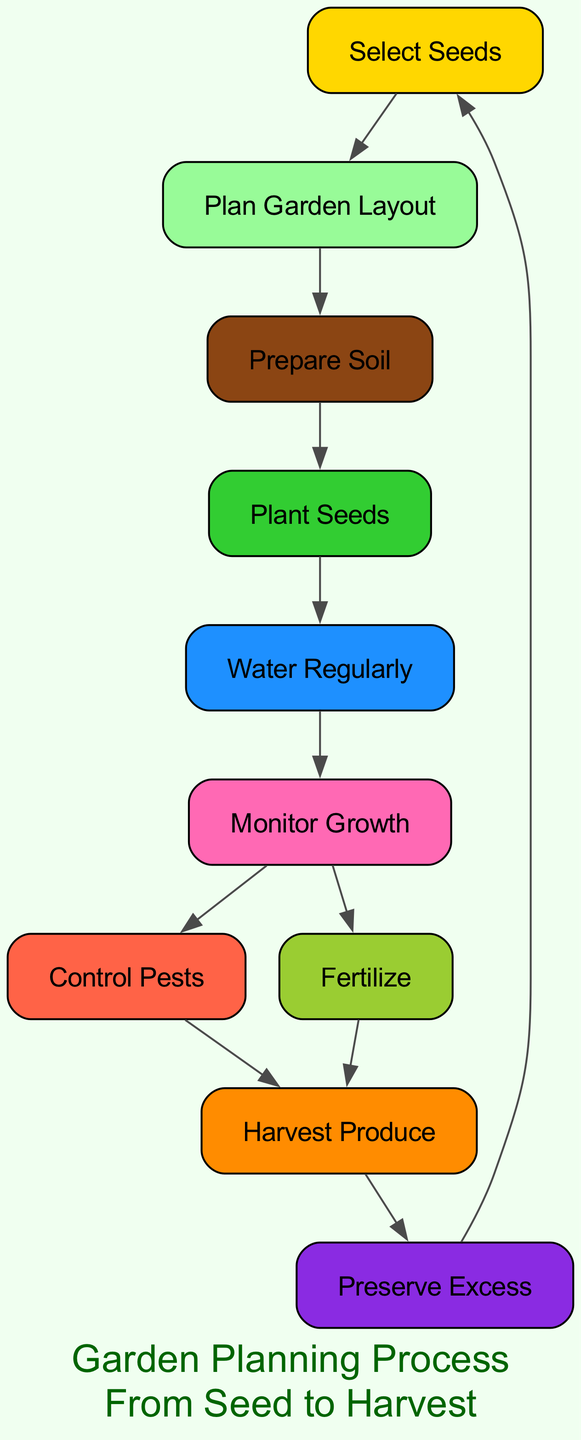What is the first step in the garden planning process? The first node in the diagram is "Select Seeds", which indicates that this is the starting point of the garden planning process.
Answer: Select Seeds How many nodes are present in the diagram? The diagram lists 10 different nodes related to the garden planning process. By counting each unique node, we confirm the total.
Answer: 10 What is the relationship between "Plant Seeds" and "Water Regularly"? The diagram shows a directed edge from "Plant Seeds" to "Water Regularly", indicating that watering occurs after planting seeds.
Answer: "Plant Seeds" to "Water Regularly" Which step comes after "Monitor Growth"? From the diagram, "Control Pests" and "Fertilize" both follow "Monitor Growth" as indicated by the directed edges leading from "Monitor Growth".
Answer: Control Pests, Fertilize What node immediately precedes "Harvest Produce"? The diagram indicates two nodes lead directly to "Harvest Produce", which are "Control Pests" and "Fertilize", making either the immediate predecessor.
Answer: Control Pests, Fertilize What color represents the "Prepare Soil" stage? The diagram uses a specific color for the "Prepare Soil" node, which is saddle brown, as indicated in the predefined colors for stages in the diagram.
Answer: Saddle brown How many edges are there in the diagram? By counting the relationships between the nodes, there are 10 directed edges connecting them in the garden planning process.
Answer: 10 What is the last step in the garden planning process? According to the final node in the directed graph, "Preserve Excess" is the last step noted, indicating it comes after harvesting the produce.
Answer: Preserve Excess Which stage involves both monitoring growth and control of pests? The node "Monitor Growth" connects directly to "Control Pests," indicating that both stages are related and occur sequentially within the process.
Answer: Monitor Growth, Control Pests 